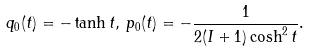<formula> <loc_0><loc_0><loc_500><loc_500>q _ { 0 } ( t ) = - \tanh t , \, p _ { 0 } ( t ) = - \frac { 1 } { 2 ( I + 1 ) \cosh ^ { 2 } t } .</formula> 